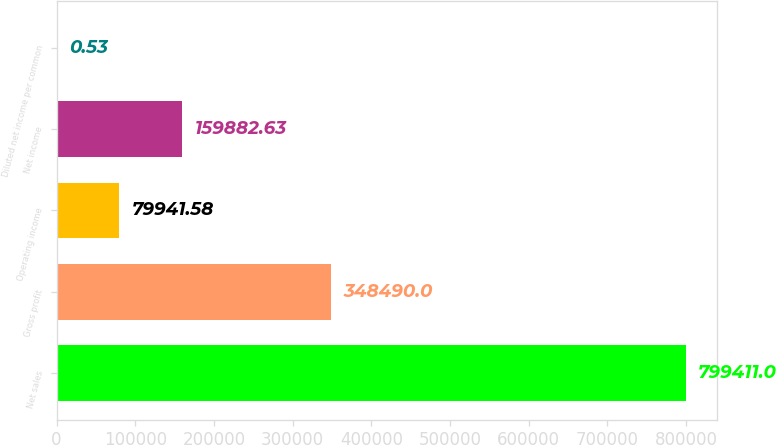Convert chart to OTSL. <chart><loc_0><loc_0><loc_500><loc_500><bar_chart><fcel>Net sales<fcel>Gross profit<fcel>Operating income<fcel>Net income<fcel>Diluted net income per common<nl><fcel>799411<fcel>348490<fcel>79941.6<fcel>159883<fcel>0.53<nl></chart> 